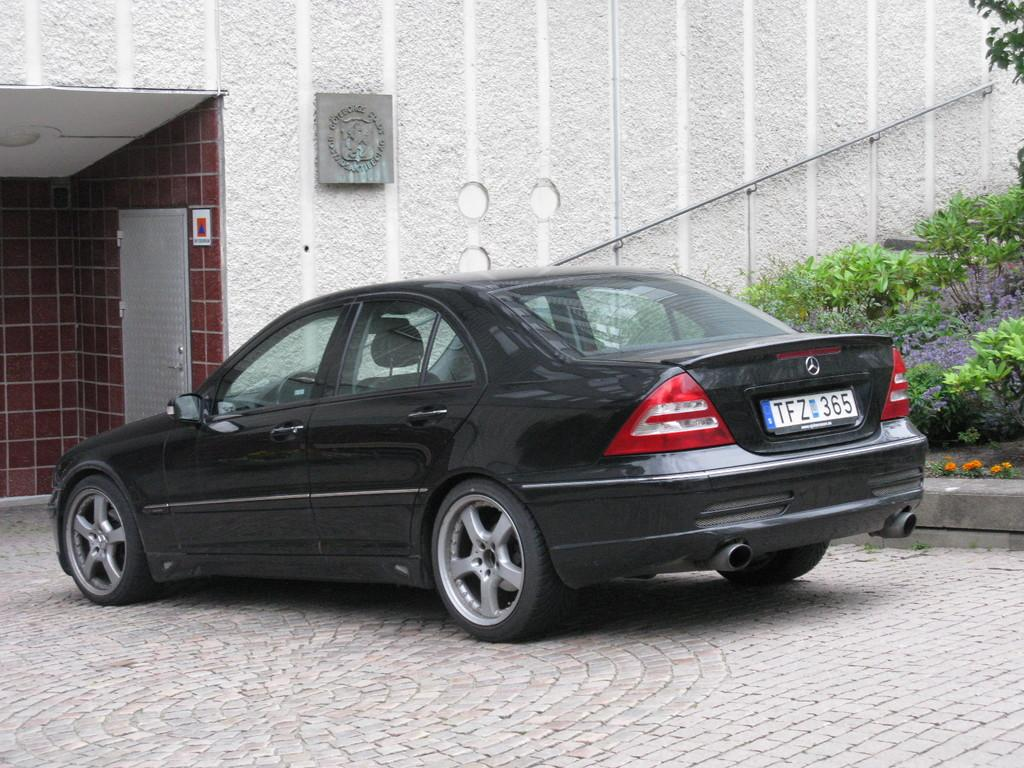What is on the ground in the image? There is a car on the ground in the image. What type of vegetation can be seen in the image? There are plants visible in the image. What is the background of the image made of? There is a wall in the image, which serves as the background. What note is the pig playing in the image? There is no pig or musical instrument present in the image. 